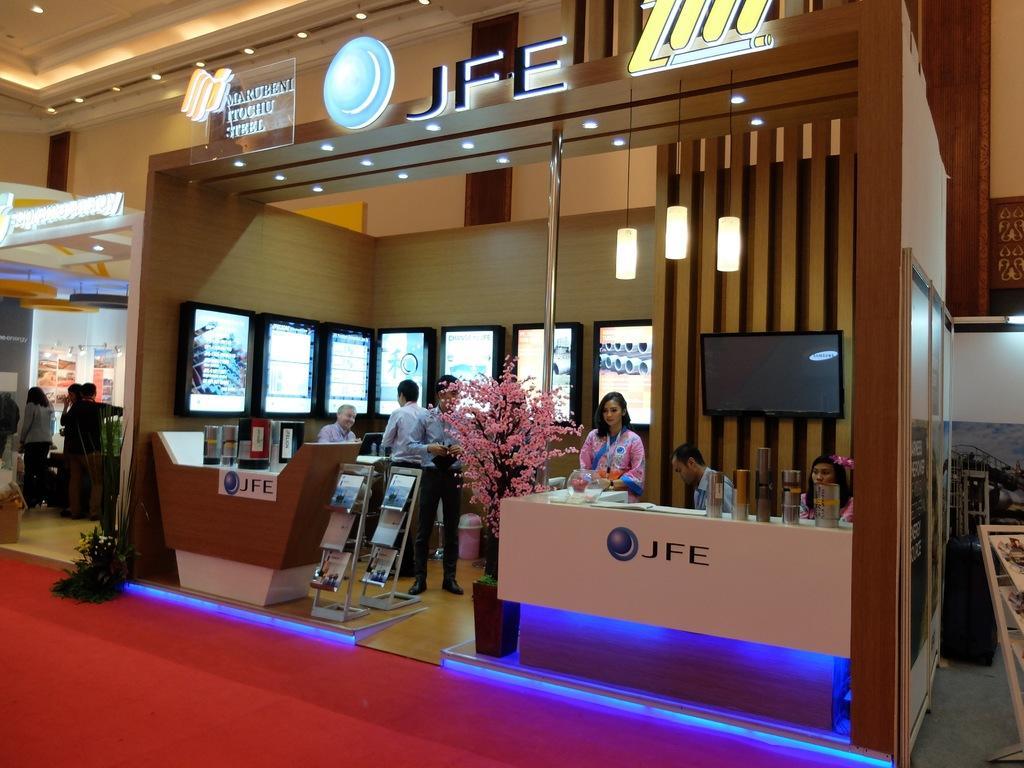Describe this image in one or two sentences. In this image I can see the inner view of the building. Inside the building I can see the group of people with different color dresses. I can see few books in the stand. In the background I can see the screens and the boards. To the left I can see the plant. I can see the lights at the top. 